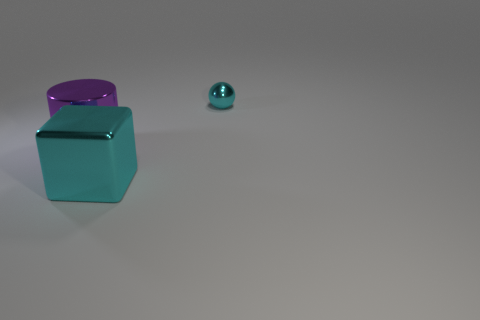Add 1 big cylinders. How many objects exist? 4 Subtract 0 yellow balls. How many objects are left? 3 Subtract all cylinders. How many objects are left? 2 Subtract all big brown shiny things. Subtract all cyan metallic spheres. How many objects are left? 2 Add 1 big cyan things. How many big cyan things are left? 2 Add 1 small gray shiny objects. How many small gray shiny objects exist? 1 